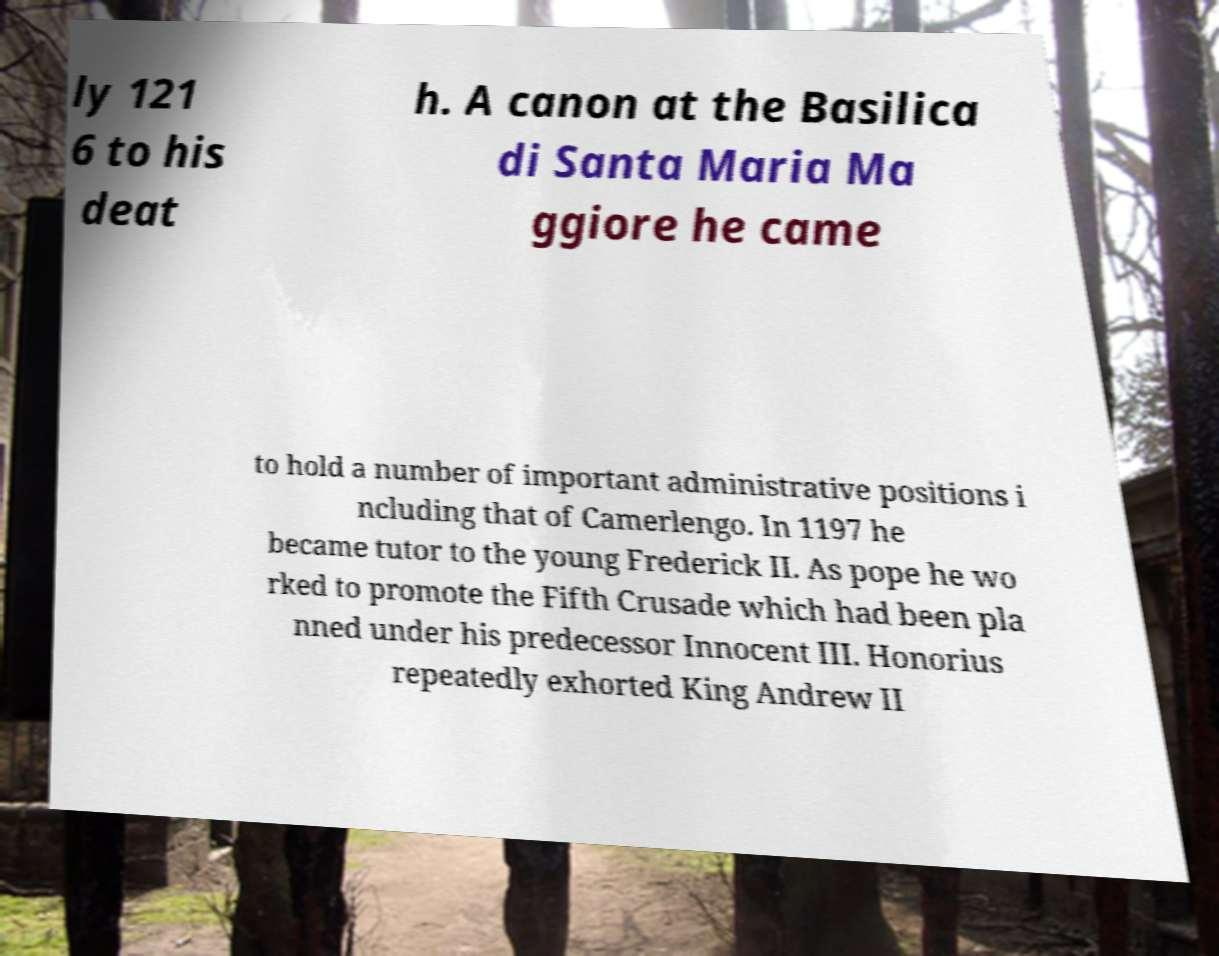What messages or text are displayed in this image? I need them in a readable, typed format. ly 121 6 to his deat h. A canon at the Basilica di Santa Maria Ma ggiore he came to hold a number of important administrative positions i ncluding that of Camerlengo. In 1197 he became tutor to the young Frederick II. As pope he wo rked to promote the Fifth Crusade which had been pla nned under his predecessor Innocent III. Honorius repeatedly exhorted King Andrew II 